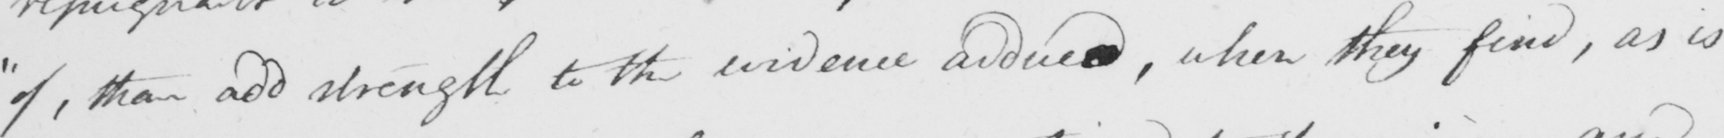What text is written in this handwritten line? " of , than add strength to the evidence adduced , when they find , as is 